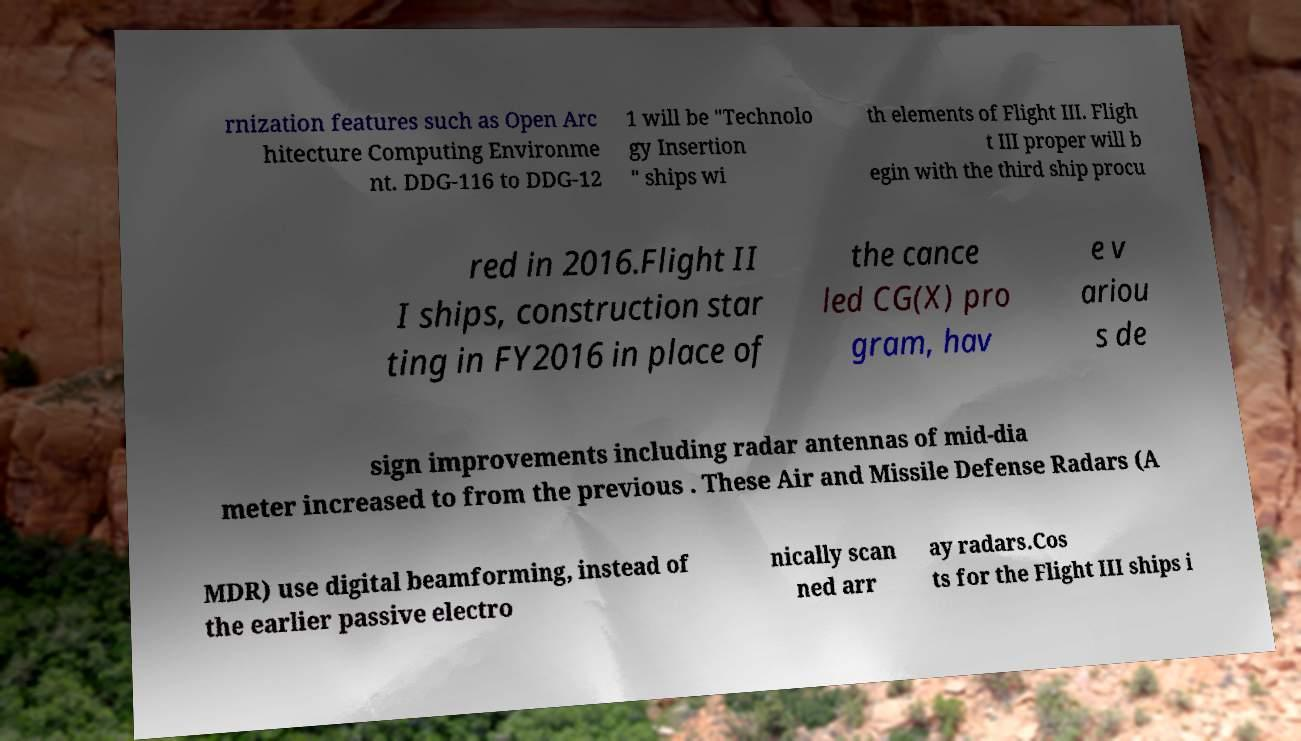For documentation purposes, I need the text within this image transcribed. Could you provide that? rnization features such as Open Arc hitecture Computing Environme nt. DDG-116 to DDG-12 1 will be "Technolo gy Insertion " ships wi th elements of Flight III. Fligh t III proper will b egin with the third ship procu red in 2016.Flight II I ships, construction star ting in FY2016 in place of the cance led CG(X) pro gram, hav e v ariou s de sign improvements including radar antennas of mid-dia meter increased to from the previous . These Air and Missile Defense Radars (A MDR) use digital beamforming, instead of the earlier passive electro nically scan ned arr ay radars.Cos ts for the Flight III ships i 